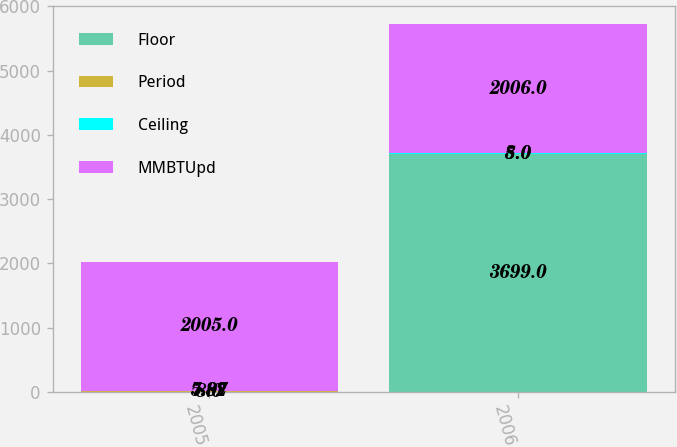<chart> <loc_0><loc_0><loc_500><loc_500><stacked_bar_chart><ecel><fcel>2005<fcel>2006<nl><fcel>Floor<fcel>8<fcel>3699<nl><fcel>Period<fcel>5.07<fcel>5<nl><fcel>Ceiling<fcel>7.82<fcel>8<nl><fcel>MMBTUpd<fcel>2005<fcel>2006<nl></chart> 